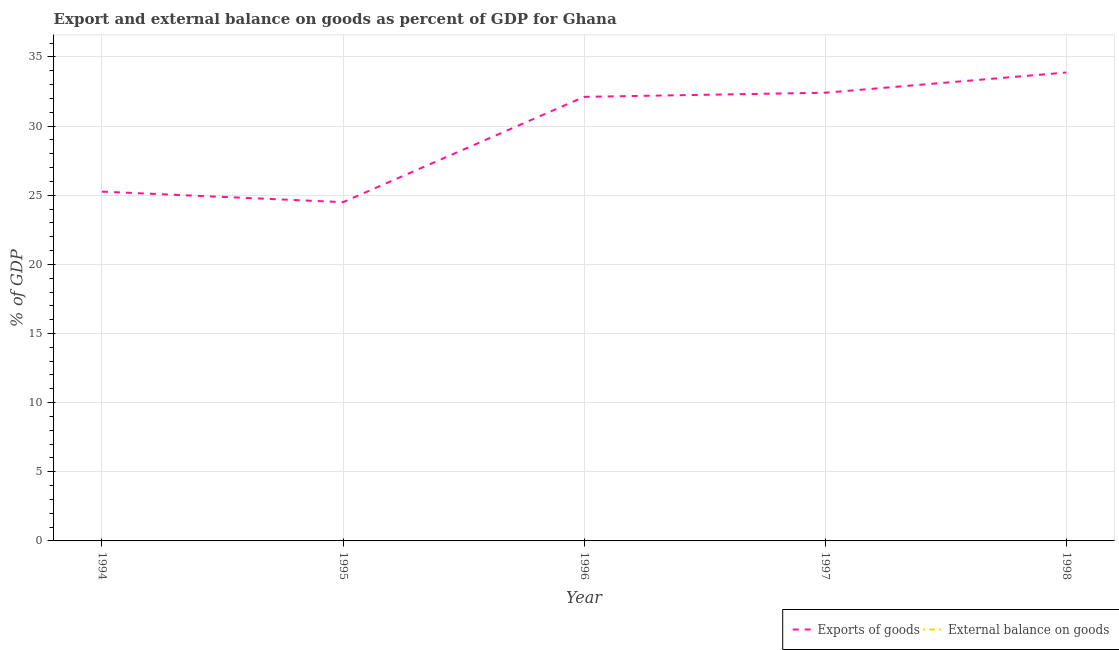How many different coloured lines are there?
Offer a very short reply. 1. Is the number of lines equal to the number of legend labels?
Offer a very short reply. No. What is the export of goods as percentage of gdp in 1996?
Offer a terse response. 32.11. Across all years, what is the maximum export of goods as percentage of gdp?
Provide a succinct answer. 33.87. Across all years, what is the minimum export of goods as percentage of gdp?
Your answer should be compact. 24.5. What is the total external balance on goods as percentage of gdp in the graph?
Your answer should be compact. 0. What is the difference between the export of goods as percentage of gdp in 1994 and that in 1996?
Your response must be concise. -6.85. What is the difference between the external balance on goods as percentage of gdp in 1994 and the export of goods as percentage of gdp in 1995?
Your answer should be very brief. -24.5. What is the average export of goods as percentage of gdp per year?
Provide a short and direct response. 29.63. In how many years, is the external balance on goods as percentage of gdp greater than 28 %?
Keep it short and to the point. 0. What is the ratio of the export of goods as percentage of gdp in 1997 to that in 1998?
Ensure brevity in your answer.  0.96. What is the difference between the highest and the second highest export of goods as percentage of gdp?
Your answer should be very brief. 1.46. What is the difference between the highest and the lowest export of goods as percentage of gdp?
Your answer should be compact. 9.37. Does the export of goods as percentage of gdp monotonically increase over the years?
Provide a short and direct response. No. Is the export of goods as percentage of gdp strictly less than the external balance on goods as percentage of gdp over the years?
Offer a very short reply. No. How many lines are there?
Make the answer very short. 1. How many years are there in the graph?
Offer a terse response. 5. Are the values on the major ticks of Y-axis written in scientific E-notation?
Your answer should be compact. No. Does the graph contain grids?
Your answer should be compact. Yes. Where does the legend appear in the graph?
Provide a succinct answer. Bottom right. What is the title of the graph?
Make the answer very short. Export and external balance on goods as percent of GDP for Ghana. What is the label or title of the X-axis?
Make the answer very short. Year. What is the label or title of the Y-axis?
Your response must be concise. % of GDP. What is the % of GDP in Exports of goods in 1994?
Offer a terse response. 25.26. What is the % of GDP of External balance on goods in 1994?
Provide a succinct answer. 0. What is the % of GDP of Exports of goods in 1995?
Provide a short and direct response. 24.5. What is the % of GDP in Exports of goods in 1996?
Provide a succinct answer. 32.11. What is the % of GDP in External balance on goods in 1996?
Offer a terse response. 0. What is the % of GDP in Exports of goods in 1997?
Offer a very short reply. 32.41. What is the % of GDP of Exports of goods in 1998?
Ensure brevity in your answer.  33.87. Across all years, what is the maximum % of GDP in Exports of goods?
Provide a succinct answer. 33.87. Across all years, what is the minimum % of GDP in Exports of goods?
Provide a succinct answer. 24.5. What is the total % of GDP in Exports of goods in the graph?
Ensure brevity in your answer.  148.15. What is the total % of GDP of External balance on goods in the graph?
Offer a very short reply. 0. What is the difference between the % of GDP of Exports of goods in 1994 and that in 1995?
Provide a succinct answer. 0.76. What is the difference between the % of GDP of Exports of goods in 1994 and that in 1996?
Keep it short and to the point. -6.85. What is the difference between the % of GDP of Exports of goods in 1994 and that in 1997?
Make the answer very short. -7.15. What is the difference between the % of GDP of Exports of goods in 1994 and that in 1998?
Your answer should be compact. -8.61. What is the difference between the % of GDP in Exports of goods in 1995 and that in 1996?
Offer a very short reply. -7.62. What is the difference between the % of GDP of Exports of goods in 1995 and that in 1997?
Provide a succinct answer. -7.91. What is the difference between the % of GDP of Exports of goods in 1995 and that in 1998?
Provide a succinct answer. -9.37. What is the difference between the % of GDP of Exports of goods in 1996 and that in 1997?
Provide a short and direct response. -0.3. What is the difference between the % of GDP in Exports of goods in 1996 and that in 1998?
Make the answer very short. -1.76. What is the difference between the % of GDP in Exports of goods in 1997 and that in 1998?
Provide a succinct answer. -1.46. What is the average % of GDP of Exports of goods per year?
Your answer should be compact. 29.63. What is the average % of GDP of External balance on goods per year?
Provide a short and direct response. 0. What is the ratio of the % of GDP of Exports of goods in 1994 to that in 1995?
Offer a terse response. 1.03. What is the ratio of the % of GDP of Exports of goods in 1994 to that in 1996?
Provide a succinct answer. 0.79. What is the ratio of the % of GDP of Exports of goods in 1994 to that in 1997?
Give a very brief answer. 0.78. What is the ratio of the % of GDP of Exports of goods in 1994 to that in 1998?
Your answer should be very brief. 0.75. What is the ratio of the % of GDP in Exports of goods in 1995 to that in 1996?
Ensure brevity in your answer.  0.76. What is the ratio of the % of GDP of Exports of goods in 1995 to that in 1997?
Give a very brief answer. 0.76. What is the ratio of the % of GDP of Exports of goods in 1995 to that in 1998?
Your answer should be very brief. 0.72. What is the ratio of the % of GDP in Exports of goods in 1996 to that in 1997?
Offer a terse response. 0.99. What is the ratio of the % of GDP in Exports of goods in 1996 to that in 1998?
Offer a terse response. 0.95. What is the ratio of the % of GDP in Exports of goods in 1997 to that in 1998?
Offer a terse response. 0.96. What is the difference between the highest and the second highest % of GDP in Exports of goods?
Provide a short and direct response. 1.46. What is the difference between the highest and the lowest % of GDP of Exports of goods?
Provide a succinct answer. 9.37. 